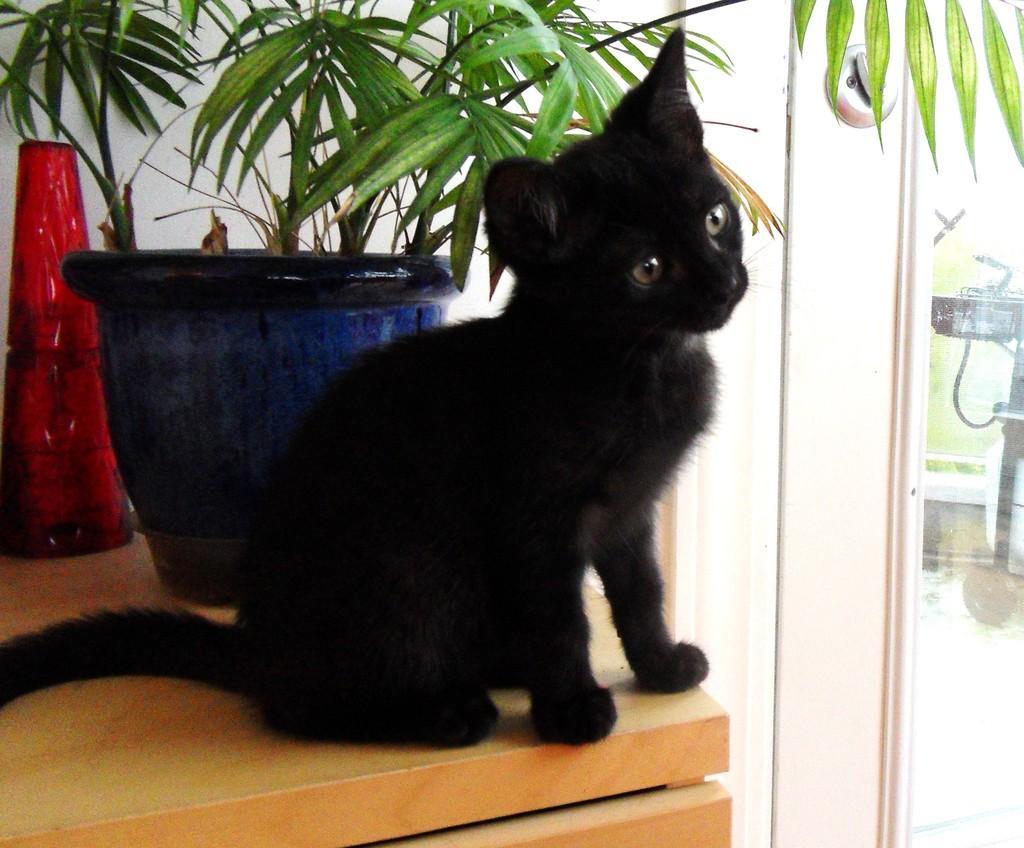Please provide a concise description of this image. In this picture we can see a black cat and a houseplant on a wooden platform and in the background we can see grass and an object. 